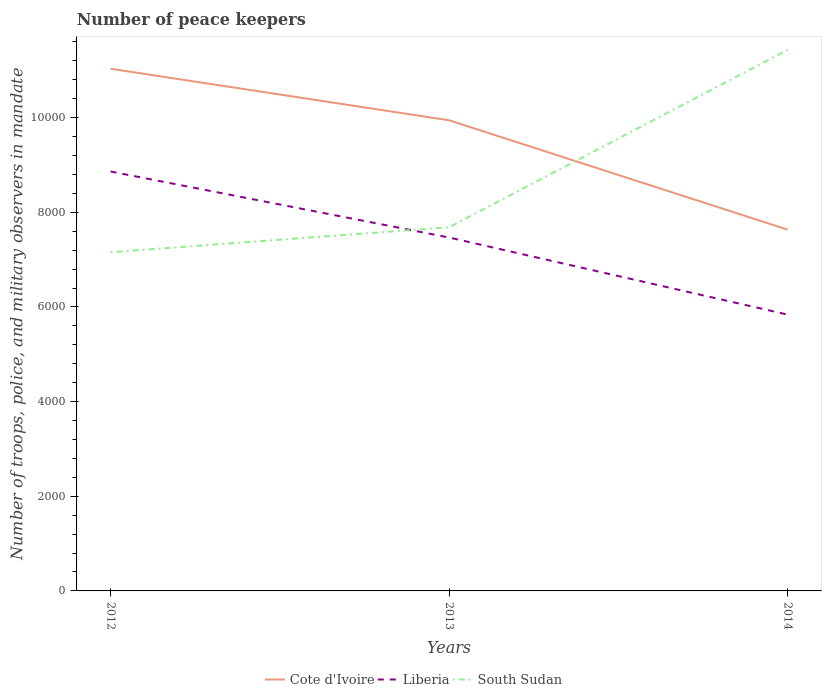How many different coloured lines are there?
Make the answer very short. 3. Does the line corresponding to Cote d'Ivoire intersect with the line corresponding to Liberia?
Your answer should be very brief. No. Across all years, what is the maximum number of peace keepers in in Liberia?
Provide a succinct answer. 5838. In which year was the number of peace keepers in in Cote d'Ivoire maximum?
Your response must be concise. 2014. What is the total number of peace keepers in in Cote d'Ivoire in the graph?
Offer a very short reply. 1089. What is the difference between the highest and the second highest number of peace keepers in in Cote d'Ivoire?
Provide a short and direct response. 3400. What is the difference between the highest and the lowest number of peace keepers in in Cote d'Ivoire?
Provide a short and direct response. 2. What is the difference between two consecutive major ticks on the Y-axis?
Provide a short and direct response. 2000. Are the values on the major ticks of Y-axis written in scientific E-notation?
Provide a short and direct response. No. Does the graph contain grids?
Your answer should be compact. No. How many legend labels are there?
Your response must be concise. 3. How are the legend labels stacked?
Ensure brevity in your answer.  Horizontal. What is the title of the graph?
Your answer should be compact. Number of peace keepers. What is the label or title of the Y-axis?
Your response must be concise. Number of troops, police, and military observers in mandate. What is the Number of troops, police, and military observers in mandate of Cote d'Ivoire in 2012?
Your answer should be compact. 1.10e+04. What is the Number of troops, police, and military observers in mandate in Liberia in 2012?
Make the answer very short. 8862. What is the Number of troops, police, and military observers in mandate of South Sudan in 2012?
Your answer should be very brief. 7157. What is the Number of troops, police, and military observers in mandate in Cote d'Ivoire in 2013?
Keep it short and to the point. 9944. What is the Number of troops, police, and military observers in mandate of Liberia in 2013?
Provide a short and direct response. 7467. What is the Number of troops, police, and military observers in mandate of South Sudan in 2013?
Make the answer very short. 7684. What is the Number of troops, police, and military observers in mandate in Cote d'Ivoire in 2014?
Your answer should be compact. 7633. What is the Number of troops, police, and military observers in mandate in Liberia in 2014?
Make the answer very short. 5838. What is the Number of troops, police, and military observers in mandate in South Sudan in 2014?
Give a very brief answer. 1.14e+04. Across all years, what is the maximum Number of troops, police, and military observers in mandate of Cote d'Ivoire?
Make the answer very short. 1.10e+04. Across all years, what is the maximum Number of troops, police, and military observers in mandate of Liberia?
Provide a succinct answer. 8862. Across all years, what is the maximum Number of troops, police, and military observers in mandate of South Sudan?
Offer a very short reply. 1.14e+04. Across all years, what is the minimum Number of troops, police, and military observers in mandate of Cote d'Ivoire?
Make the answer very short. 7633. Across all years, what is the minimum Number of troops, police, and military observers in mandate of Liberia?
Offer a terse response. 5838. Across all years, what is the minimum Number of troops, police, and military observers in mandate in South Sudan?
Provide a short and direct response. 7157. What is the total Number of troops, police, and military observers in mandate in Cote d'Ivoire in the graph?
Give a very brief answer. 2.86e+04. What is the total Number of troops, police, and military observers in mandate in Liberia in the graph?
Offer a terse response. 2.22e+04. What is the total Number of troops, police, and military observers in mandate of South Sudan in the graph?
Provide a short and direct response. 2.63e+04. What is the difference between the Number of troops, police, and military observers in mandate in Cote d'Ivoire in 2012 and that in 2013?
Make the answer very short. 1089. What is the difference between the Number of troops, police, and military observers in mandate of Liberia in 2012 and that in 2013?
Give a very brief answer. 1395. What is the difference between the Number of troops, police, and military observers in mandate in South Sudan in 2012 and that in 2013?
Provide a succinct answer. -527. What is the difference between the Number of troops, police, and military observers in mandate in Cote d'Ivoire in 2012 and that in 2014?
Your answer should be compact. 3400. What is the difference between the Number of troops, police, and military observers in mandate in Liberia in 2012 and that in 2014?
Keep it short and to the point. 3024. What is the difference between the Number of troops, police, and military observers in mandate in South Sudan in 2012 and that in 2014?
Make the answer very short. -4276. What is the difference between the Number of troops, police, and military observers in mandate in Cote d'Ivoire in 2013 and that in 2014?
Make the answer very short. 2311. What is the difference between the Number of troops, police, and military observers in mandate of Liberia in 2013 and that in 2014?
Offer a very short reply. 1629. What is the difference between the Number of troops, police, and military observers in mandate of South Sudan in 2013 and that in 2014?
Your answer should be very brief. -3749. What is the difference between the Number of troops, police, and military observers in mandate in Cote d'Ivoire in 2012 and the Number of troops, police, and military observers in mandate in Liberia in 2013?
Ensure brevity in your answer.  3566. What is the difference between the Number of troops, police, and military observers in mandate in Cote d'Ivoire in 2012 and the Number of troops, police, and military observers in mandate in South Sudan in 2013?
Give a very brief answer. 3349. What is the difference between the Number of troops, police, and military observers in mandate in Liberia in 2012 and the Number of troops, police, and military observers in mandate in South Sudan in 2013?
Your answer should be very brief. 1178. What is the difference between the Number of troops, police, and military observers in mandate of Cote d'Ivoire in 2012 and the Number of troops, police, and military observers in mandate of Liberia in 2014?
Make the answer very short. 5195. What is the difference between the Number of troops, police, and military observers in mandate of Cote d'Ivoire in 2012 and the Number of troops, police, and military observers in mandate of South Sudan in 2014?
Make the answer very short. -400. What is the difference between the Number of troops, police, and military observers in mandate of Liberia in 2012 and the Number of troops, police, and military observers in mandate of South Sudan in 2014?
Give a very brief answer. -2571. What is the difference between the Number of troops, police, and military observers in mandate of Cote d'Ivoire in 2013 and the Number of troops, police, and military observers in mandate of Liberia in 2014?
Your answer should be very brief. 4106. What is the difference between the Number of troops, police, and military observers in mandate in Cote d'Ivoire in 2013 and the Number of troops, police, and military observers in mandate in South Sudan in 2014?
Give a very brief answer. -1489. What is the difference between the Number of troops, police, and military observers in mandate in Liberia in 2013 and the Number of troops, police, and military observers in mandate in South Sudan in 2014?
Offer a very short reply. -3966. What is the average Number of troops, police, and military observers in mandate in Cote d'Ivoire per year?
Offer a terse response. 9536.67. What is the average Number of troops, police, and military observers in mandate in Liberia per year?
Ensure brevity in your answer.  7389. What is the average Number of troops, police, and military observers in mandate of South Sudan per year?
Give a very brief answer. 8758. In the year 2012, what is the difference between the Number of troops, police, and military observers in mandate of Cote d'Ivoire and Number of troops, police, and military observers in mandate of Liberia?
Keep it short and to the point. 2171. In the year 2012, what is the difference between the Number of troops, police, and military observers in mandate of Cote d'Ivoire and Number of troops, police, and military observers in mandate of South Sudan?
Offer a terse response. 3876. In the year 2012, what is the difference between the Number of troops, police, and military observers in mandate of Liberia and Number of troops, police, and military observers in mandate of South Sudan?
Make the answer very short. 1705. In the year 2013, what is the difference between the Number of troops, police, and military observers in mandate of Cote d'Ivoire and Number of troops, police, and military observers in mandate of Liberia?
Your response must be concise. 2477. In the year 2013, what is the difference between the Number of troops, police, and military observers in mandate in Cote d'Ivoire and Number of troops, police, and military observers in mandate in South Sudan?
Offer a very short reply. 2260. In the year 2013, what is the difference between the Number of troops, police, and military observers in mandate of Liberia and Number of troops, police, and military observers in mandate of South Sudan?
Your answer should be compact. -217. In the year 2014, what is the difference between the Number of troops, police, and military observers in mandate in Cote d'Ivoire and Number of troops, police, and military observers in mandate in Liberia?
Provide a short and direct response. 1795. In the year 2014, what is the difference between the Number of troops, police, and military observers in mandate of Cote d'Ivoire and Number of troops, police, and military observers in mandate of South Sudan?
Your answer should be compact. -3800. In the year 2014, what is the difference between the Number of troops, police, and military observers in mandate in Liberia and Number of troops, police, and military observers in mandate in South Sudan?
Give a very brief answer. -5595. What is the ratio of the Number of troops, police, and military observers in mandate in Cote d'Ivoire in 2012 to that in 2013?
Provide a short and direct response. 1.11. What is the ratio of the Number of troops, police, and military observers in mandate of Liberia in 2012 to that in 2013?
Keep it short and to the point. 1.19. What is the ratio of the Number of troops, police, and military observers in mandate in South Sudan in 2012 to that in 2013?
Your response must be concise. 0.93. What is the ratio of the Number of troops, police, and military observers in mandate of Cote d'Ivoire in 2012 to that in 2014?
Offer a very short reply. 1.45. What is the ratio of the Number of troops, police, and military observers in mandate in Liberia in 2012 to that in 2014?
Give a very brief answer. 1.52. What is the ratio of the Number of troops, police, and military observers in mandate of South Sudan in 2012 to that in 2014?
Provide a succinct answer. 0.63. What is the ratio of the Number of troops, police, and military observers in mandate in Cote d'Ivoire in 2013 to that in 2014?
Offer a terse response. 1.3. What is the ratio of the Number of troops, police, and military observers in mandate of Liberia in 2013 to that in 2014?
Provide a succinct answer. 1.28. What is the ratio of the Number of troops, police, and military observers in mandate in South Sudan in 2013 to that in 2014?
Make the answer very short. 0.67. What is the difference between the highest and the second highest Number of troops, police, and military observers in mandate in Cote d'Ivoire?
Make the answer very short. 1089. What is the difference between the highest and the second highest Number of troops, police, and military observers in mandate of Liberia?
Ensure brevity in your answer.  1395. What is the difference between the highest and the second highest Number of troops, police, and military observers in mandate of South Sudan?
Your answer should be compact. 3749. What is the difference between the highest and the lowest Number of troops, police, and military observers in mandate in Cote d'Ivoire?
Provide a succinct answer. 3400. What is the difference between the highest and the lowest Number of troops, police, and military observers in mandate of Liberia?
Give a very brief answer. 3024. What is the difference between the highest and the lowest Number of troops, police, and military observers in mandate in South Sudan?
Keep it short and to the point. 4276. 